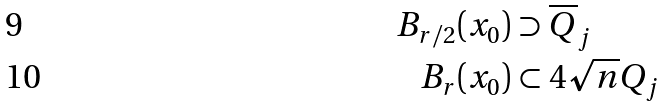Convert formula to latex. <formula><loc_0><loc_0><loc_500><loc_500>B _ { r / 2 } ( x _ { 0 } ) & \supset \overline { Q } _ { j } \\ B _ { r } ( x _ { 0 } ) & \subset 4 \sqrt { n } Q _ { j }</formula> 